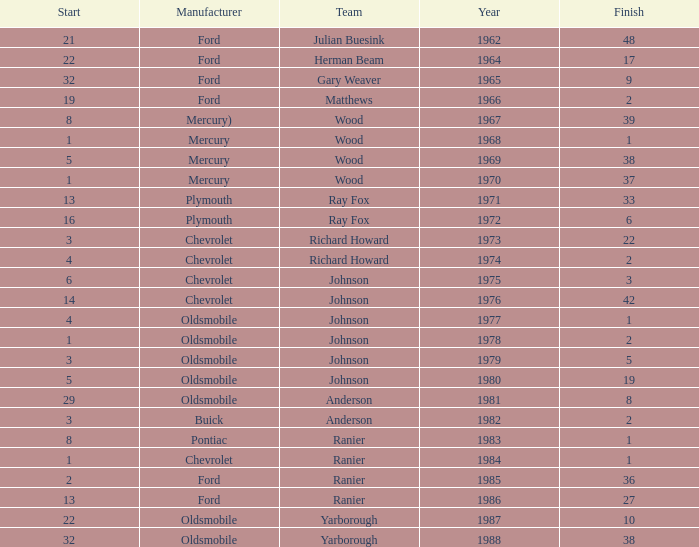What is the smallest finish time for a race after 1972 with a car manufactured by pontiac? 1.0. 